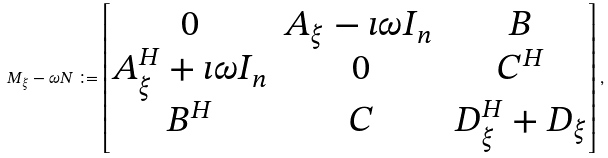Convert formula to latex. <formula><loc_0><loc_0><loc_500><loc_500>M _ { \xi } - \omega N \coloneqq \begin{bmatrix} 0 & A _ { \xi } - \imath \omega I _ { n } \, & B \\ A _ { \xi } ^ { H } + \imath \omega I _ { n } & 0 & C ^ { H } \\ B ^ { H } & C & D _ { \xi } ^ { H } + D _ { \xi } \end{bmatrix} ,</formula> 